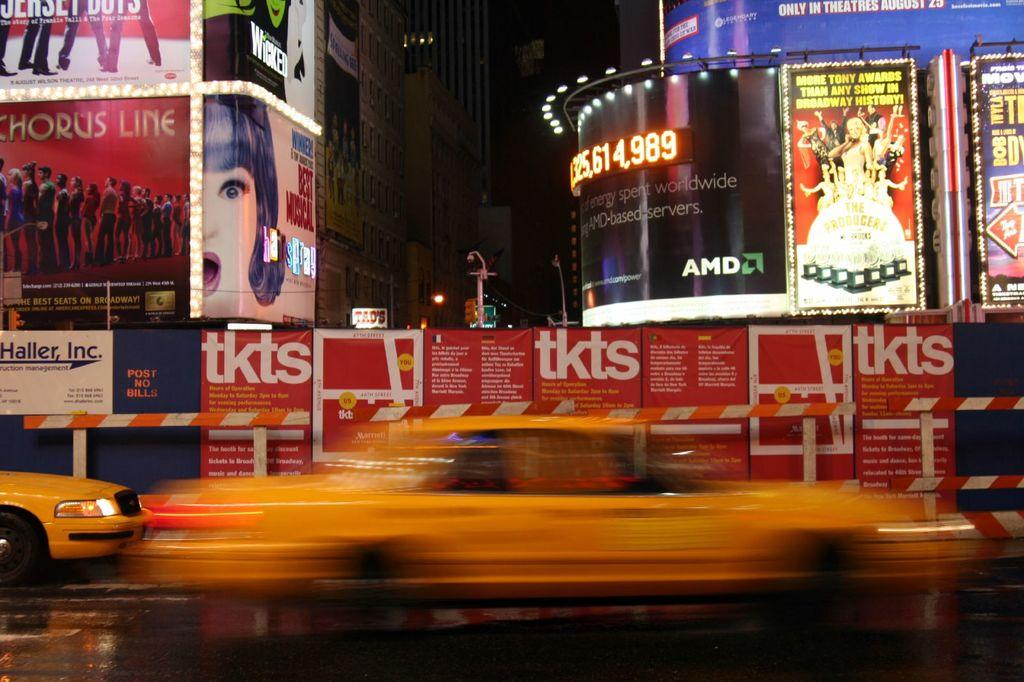<image>
Write a terse but informative summary of the picture. A busy street at night has taxis driving by and a billboard that says Chorus Line. 